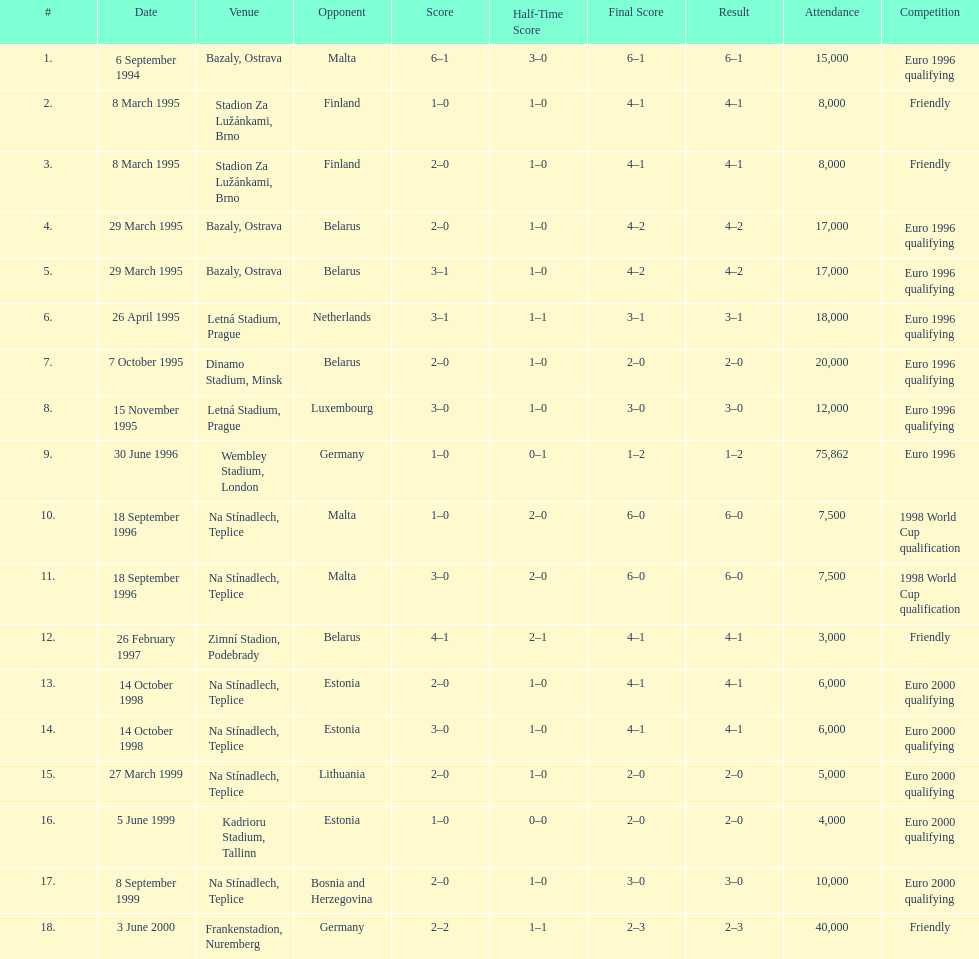Write the full table. {'header': ['#', 'Date', 'Venue', 'Opponent', 'Score', 'Half-Time Score', 'Final Score', 'Result', 'Attendance', 'Competition'], 'rows': [['1.', '6 September 1994', 'Bazaly, Ostrava', 'Malta', '6–1', '3–0', '6–1', '6–1', '15,000', 'Euro 1996 qualifying'], ['2.', '8 March 1995', 'Stadion Za Lužánkami, Brno', 'Finland', '1–0', '1–0', '4–1', '4–1', '8,000', 'Friendly'], ['3.', '8 March 1995', 'Stadion Za Lužánkami, Brno', 'Finland', '2–0', '1–0', '4–1', '4–1', '8,000', 'Friendly'], ['4.', '29 March 1995', 'Bazaly, Ostrava', 'Belarus', '2–0', '1–0', '4–2', '4–2', '17,000', 'Euro 1996 qualifying'], ['5.', '29 March 1995', 'Bazaly, Ostrava', 'Belarus', '3–1', '1–0', '4–2', '4–2', '17,000', 'Euro 1996 qualifying'], ['6.', '26 April 1995', 'Letná Stadium, Prague', 'Netherlands', '3–1', '1–1', '3–1', '3–1', '18,000', 'Euro 1996 qualifying'], ['7.', '7 October 1995', 'Dinamo Stadium, Minsk', 'Belarus', '2–0', '1–0', '2–0', '2–0', '20,000', 'Euro 1996 qualifying'], ['8.', '15 November 1995', 'Letná Stadium, Prague', 'Luxembourg', '3–0', '1–0', '3–0', '3–0', '12,000', 'Euro 1996 qualifying'], ['9.', '30 June 1996', 'Wembley Stadium, London', 'Germany', '1–0', '0–1', '1–2', '1–2', '75,862', 'Euro 1996'], ['10.', '18 September 1996', 'Na Stínadlech, Teplice', 'Malta', '1–0', '2–0', '6–0', '6–0', '7,500', '1998 World Cup qualification'], ['11.', '18 September 1996', 'Na Stínadlech, Teplice', 'Malta', '3–0', '2–0', '6–0', '6–0', '7,500', '1998 World Cup qualification'], ['12.', '26 February 1997', 'Zimní Stadion, Podebrady', 'Belarus', '4–1', '2–1', '4–1', '4–1', '3,000', 'Friendly'], ['13.', '14 October 1998', 'Na Stínadlech, Teplice', 'Estonia', '2–0', '1–0', '4–1', '4–1', '6,000', 'Euro 2000 qualifying'], ['14.', '14 October 1998', 'Na Stínadlech, Teplice', 'Estonia', '3–0', '1–0', '4–1', '4–1', '6,000', 'Euro 2000 qualifying'], ['15.', '27 March 1999', 'Na Stínadlech, Teplice', 'Lithuania', '2–0', '1–0', '2–0', '2–0', '5,000', 'Euro 2000 qualifying'], ['16.', '5 June 1999', 'Kadrioru Stadium, Tallinn', 'Estonia', '1–0', '0–0', '2–0', '2–0', '4,000', 'Euro 2000 qualifying'], ['17.', '8 September 1999', 'Na Stínadlech, Teplice', 'Bosnia and Herzegovina', '2–0', '1–0', '3–0', '3–0', '10,000', 'Euro 2000 qualifying'], ['18.', '3 June 2000', 'Frankenstadion, Nuremberg', 'Germany', '2–2', '1–1', '2–3', '2–3', '40,000', 'Friendly']]} Bazaly, ostrava was used on 6 september 1004, but what venue was used on 18 september 1996? Na Stínadlech, Teplice. 